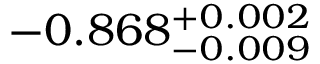<formula> <loc_0><loc_0><loc_500><loc_500>- 0 . 8 6 8 _ { - 0 . 0 0 9 } ^ { + 0 . 0 0 2 }</formula> 